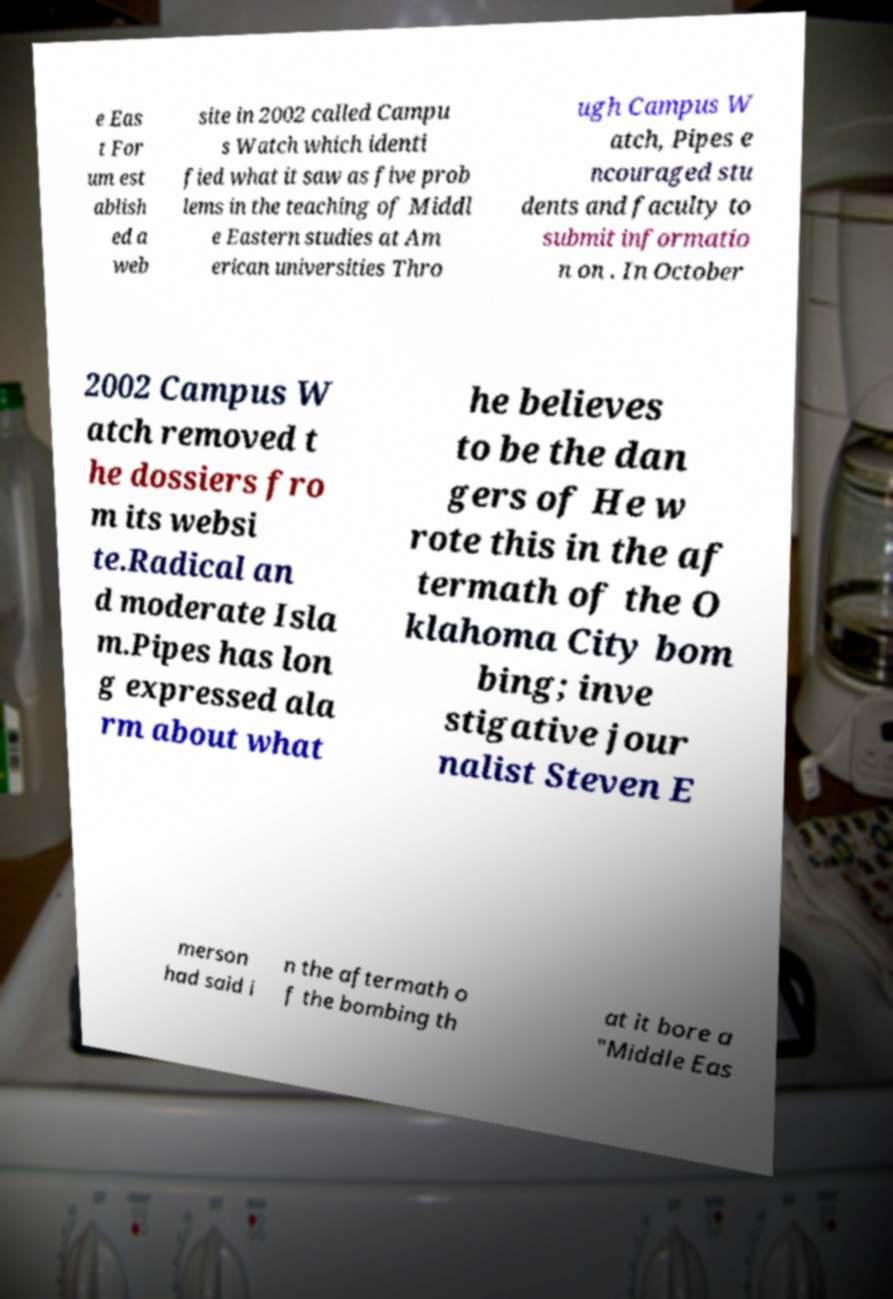For documentation purposes, I need the text within this image transcribed. Could you provide that? e Eas t For um est ablish ed a web site in 2002 called Campu s Watch which identi fied what it saw as five prob lems in the teaching of Middl e Eastern studies at Am erican universities Thro ugh Campus W atch, Pipes e ncouraged stu dents and faculty to submit informatio n on . In October 2002 Campus W atch removed t he dossiers fro m its websi te.Radical an d moderate Isla m.Pipes has lon g expressed ala rm about what he believes to be the dan gers of He w rote this in the af termath of the O klahoma City bom bing; inve stigative jour nalist Steven E merson had said i n the aftermath o f the bombing th at it bore a "Middle Eas 